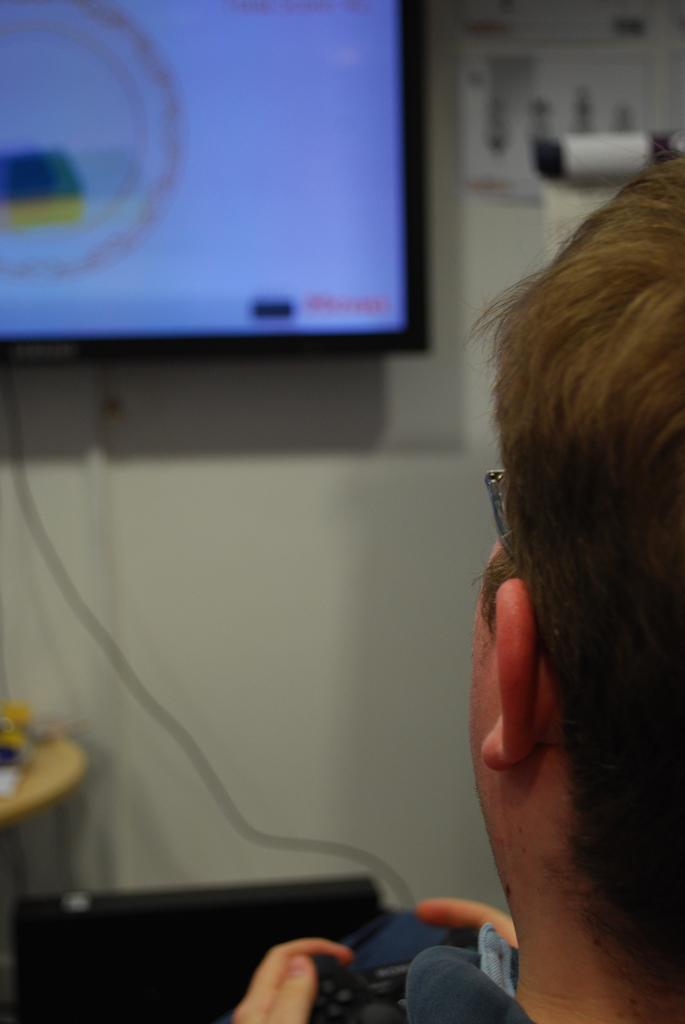What is the person in the image doing? The person is sitting on the right side of the image and holding a joystick. What can be seen on the wall in the image? There is a TV on the wall in the image. What is located beside the TV? There is a switchboard beside the TV. What type of organization is depicted in the image? There is no organization depicted in the image; it features a person sitting with a joystick, a TV on the wall, and a switchboard beside it. How many people are in the crowd in the image? There is no crowd present in the image; it only shows a single person sitting with a joystick. 